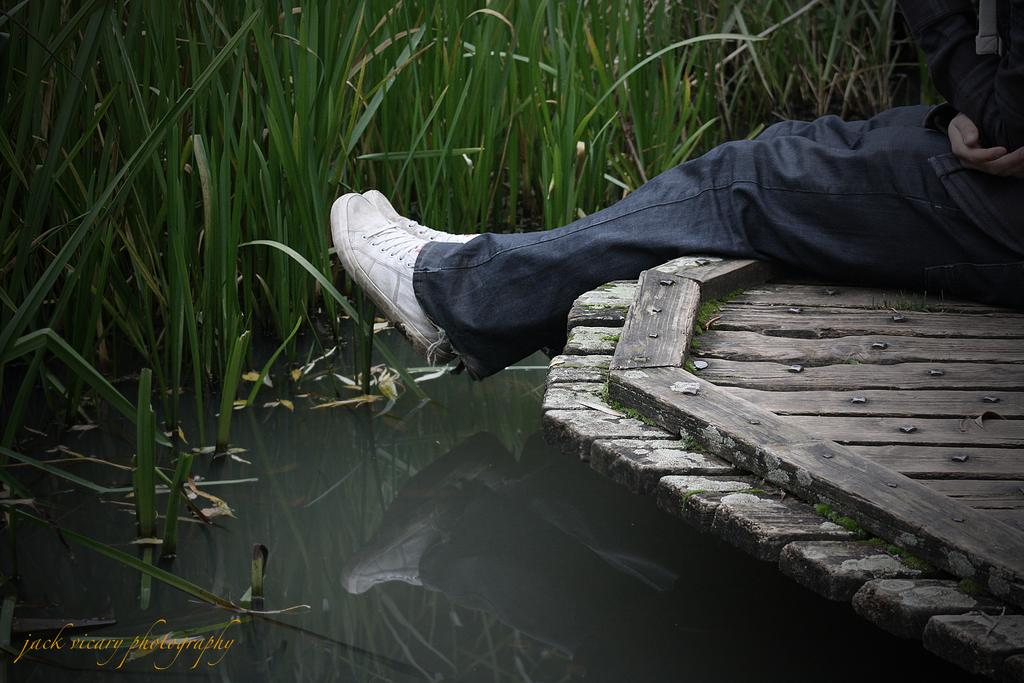What type of natural feature is present in the image? There is a lake in the image. What can be found in the lake? There are plants in the lake. Who is in the image? There is a person in the image. What is the person standing on? The person is on a wooden path. Can you see a snake slithering near the mailbox in the image? There is no snake or mailbox present in the image. 